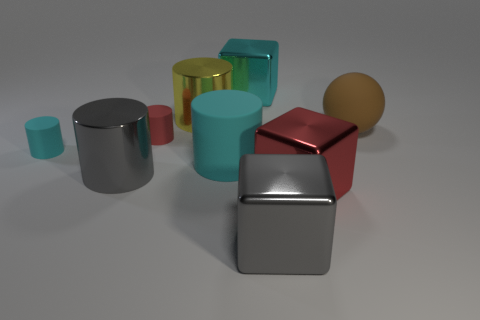How many large green shiny blocks are there?
Your response must be concise. 0. Are there any matte cubes that have the same size as the yellow thing?
Offer a very short reply. No. Are the yellow cylinder and the gray thing to the left of the gray cube made of the same material?
Offer a very short reply. Yes. There is a cube behind the yellow metal thing; what is it made of?
Your answer should be compact. Metal. The red rubber thing is what size?
Your answer should be compact. Small. Do the gray shiny thing right of the big cyan rubber cylinder and the cylinder behind the brown rubber thing have the same size?
Offer a terse response. Yes. What is the size of the gray object that is the same shape as the large cyan shiny thing?
Provide a succinct answer. Large. There is a red shiny cube; is it the same size as the cyan thing that is in front of the small cyan thing?
Offer a terse response. Yes. Is there a brown thing in front of the cyan cylinder to the right of the gray cylinder?
Make the answer very short. No. There is a cyan object behind the big brown ball; what shape is it?
Your answer should be very brief. Cube. 